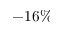<formula> <loc_0><loc_0><loc_500><loc_500>- 1 6 \%</formula> 